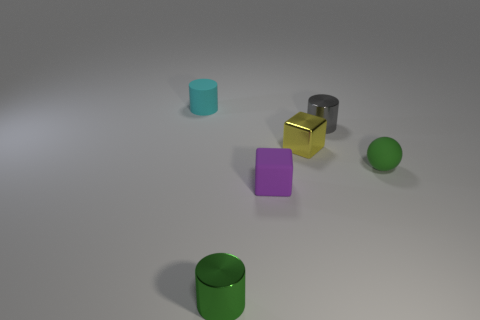Is the number of small green balls that are left of the small green rubber thing the same as the number of small cyan matte things?
Keep it short and to the point. No. Are there any other things that have the same size as the cyan matte object?
Your response must be concise. Yes. There is a cyan rubber thing that is the same size as the yellow metal thing; what shape is it?
Provide a succinct answer. Cylinder. Is there a small green metal thing of the same shape as the yellow object?
Your answer should be very brief. No. There is a small rubber cylinder that is behind the tiny purple object behind the green cylinder; is there a rubber cylinder that is on the left side of it?
Provide a succinct answer. No. Is the number of metal blocks that are in front of the sphere greater than the number of metal blocks in front of the small green shiny cylinder?
Your response must be concise. No. There is a green ball that is the same size as the yellow metal cube; what is it made of?
Provide a short and direct response. Rubber. What number of tiny objects are green cylinders or gray spheres?
Offer a terse response. 1. Does the tiny cyan matte object have the same shape as the yellow shiny thing?
Your response must be concise. No. How many things are in front of the small gray metal cylinder and behind the tiny green metallic object?
Ensure brevity in your answer.  3. 